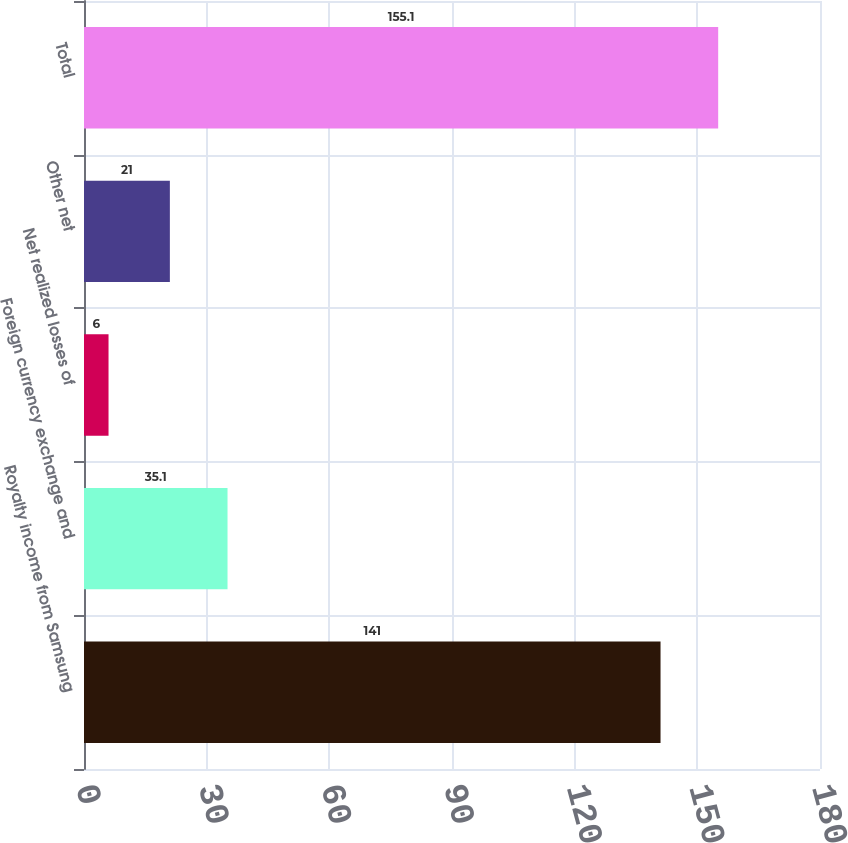Convert chart to OTSL. <chart><loc_0><loc_0><loc_500><loc_500><bar_chart><fcel>Royalty income from Samsung<fcel>Foreign currency exchange and<fcel>Net realized losses of<fcel>Other net<fcel>Total<nl><fcel>141<fcel>35.1<fcel>6<fcel>21<fcel>155.1<nl></chart> 